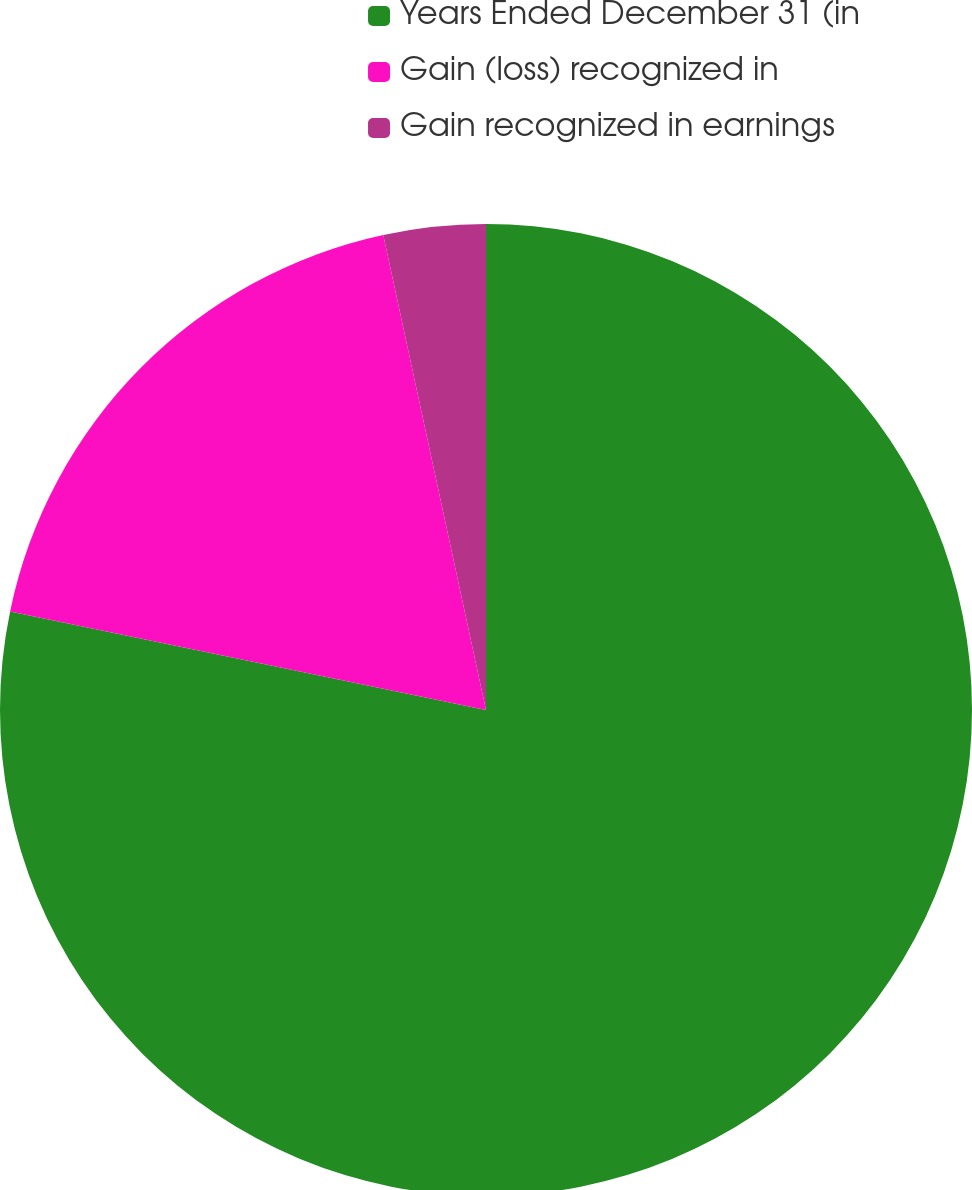<chart> <loc_0><loc_0><loc_500><loc_500><pie_chart><fcel>Years Ended December 31 (in<fcel>Gain (loss) recognized in<fcel>Gain recognized in earnings<nl><fcel>78.25%<fcel>18.36%<fcel>3.39%<nl></chart> 